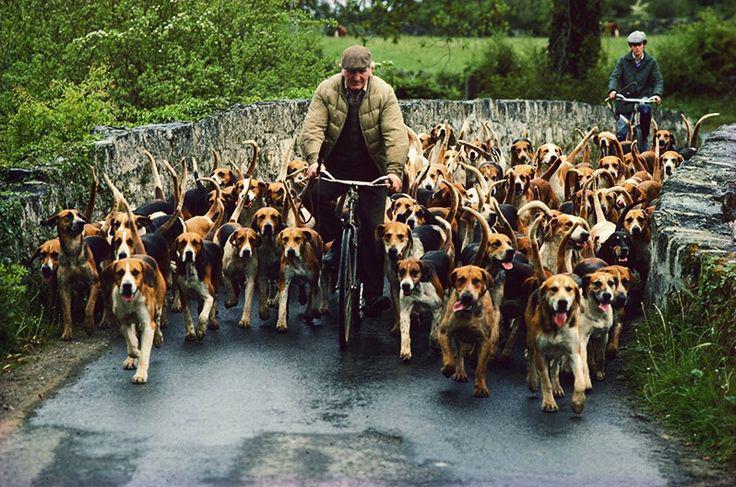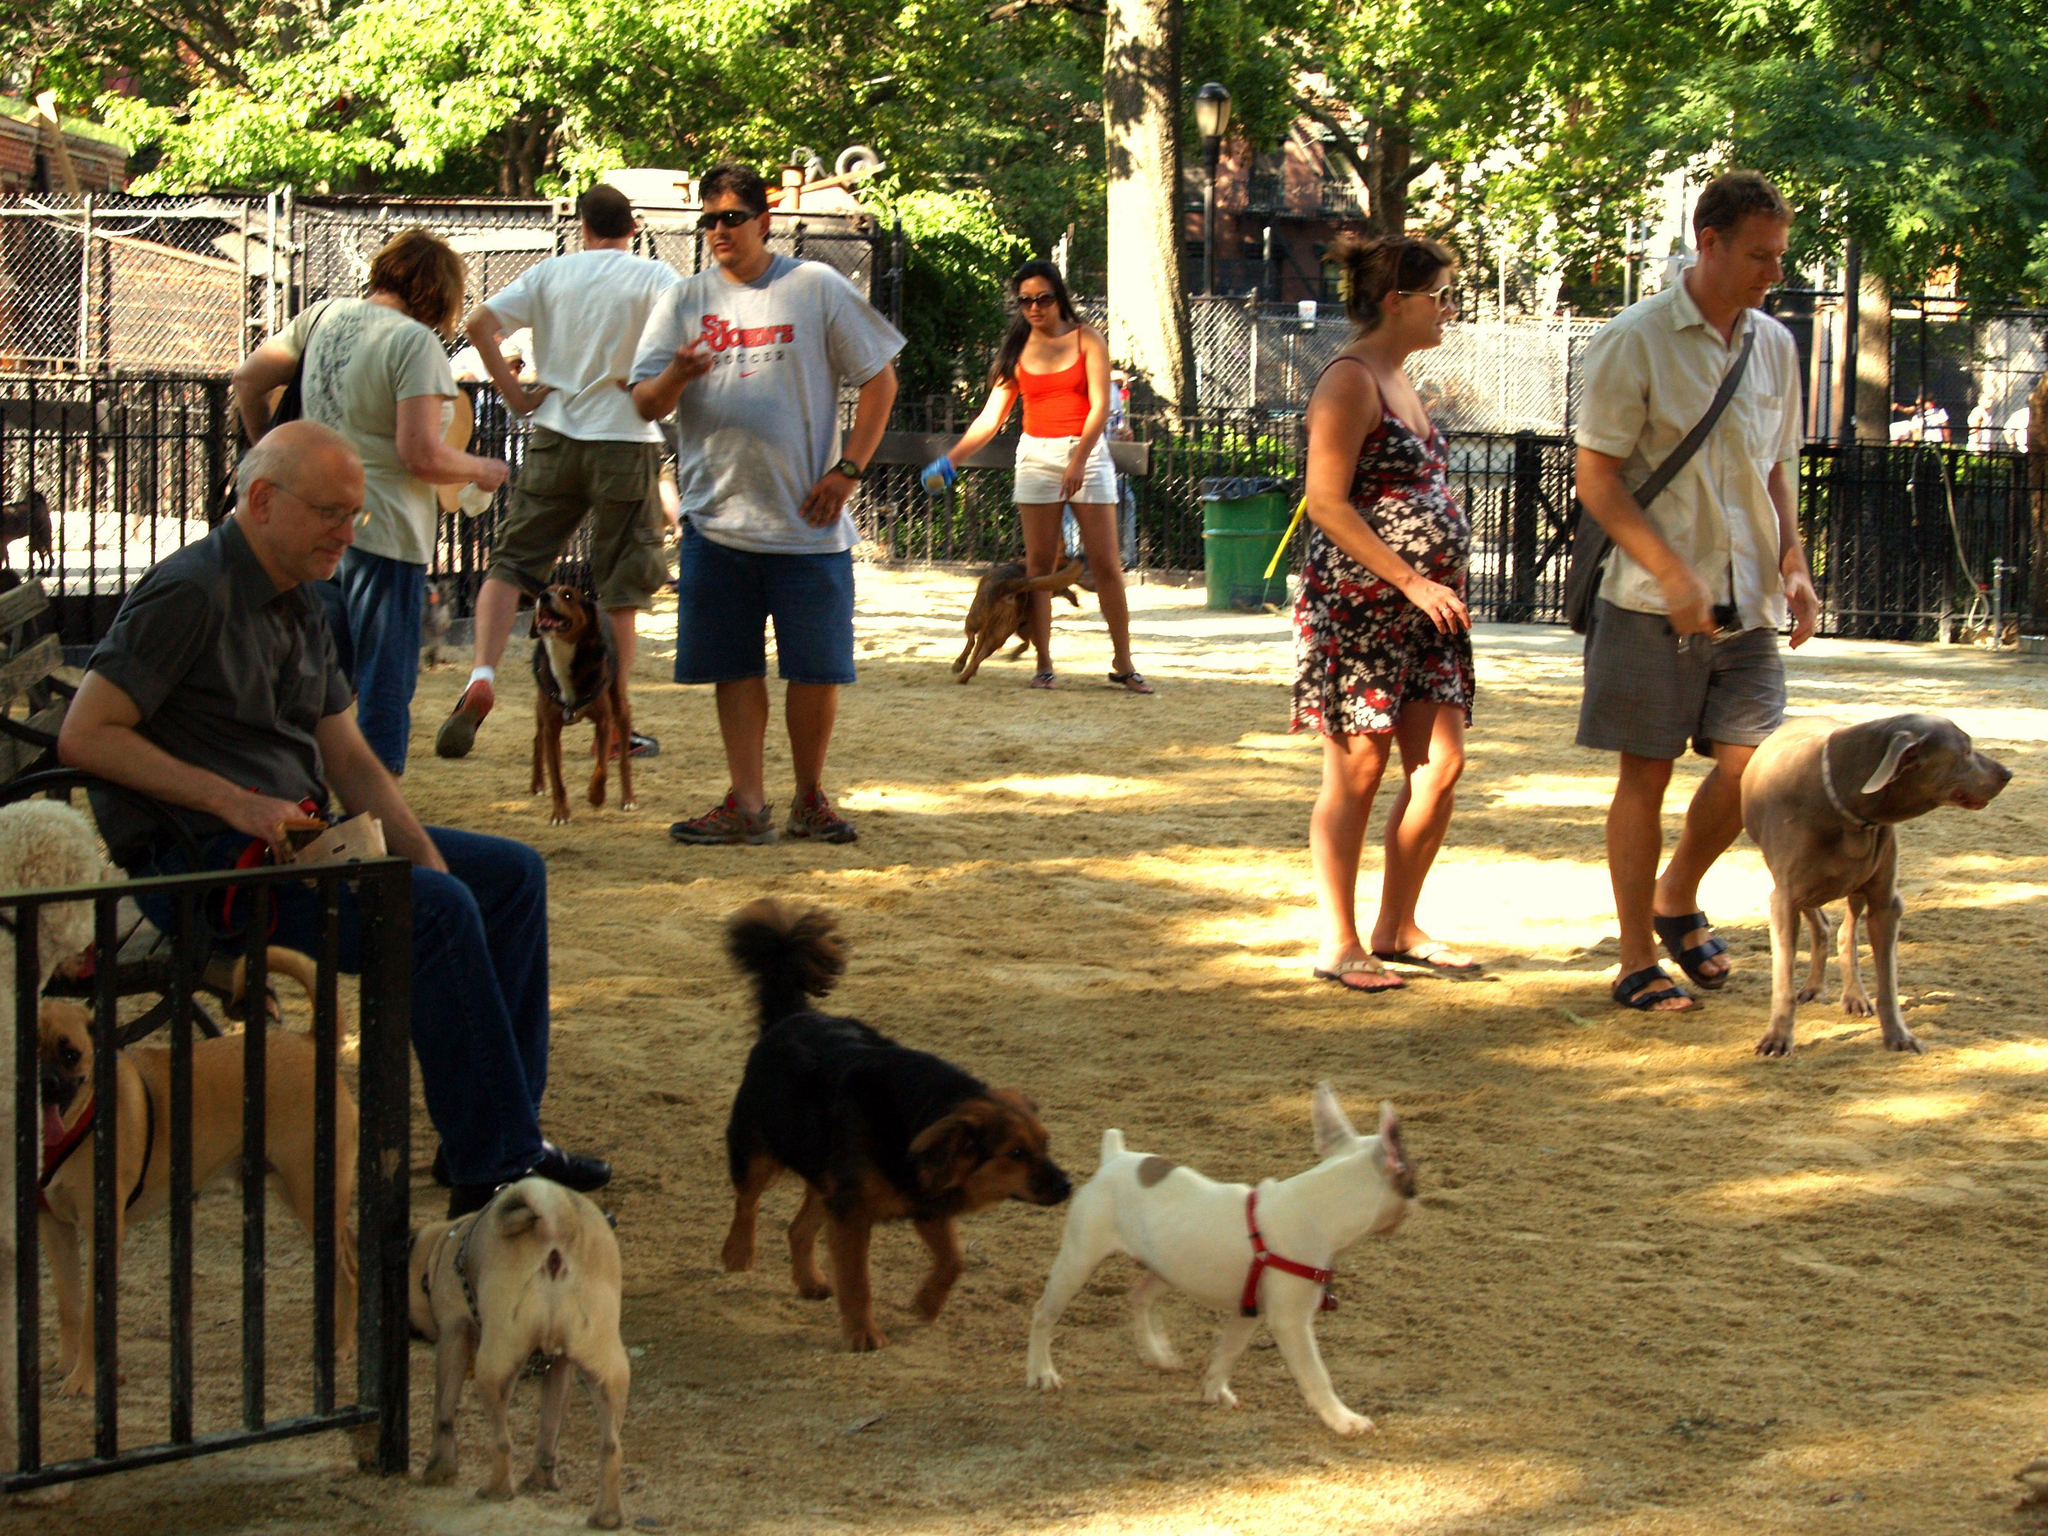The first image is the image on the left, the second image is the image on the right. Examine the images to the left and right. Is the description "An image shows a horizontal row of beagle hounds, with no humans present." accurate? Answer yes or no. No. The first image is the image on the left, the second image is the image on the right. For the images shown, is this caption "The dogs in the left image are walking toward the camera in a large group." true? Answer yes or no. Yes. 